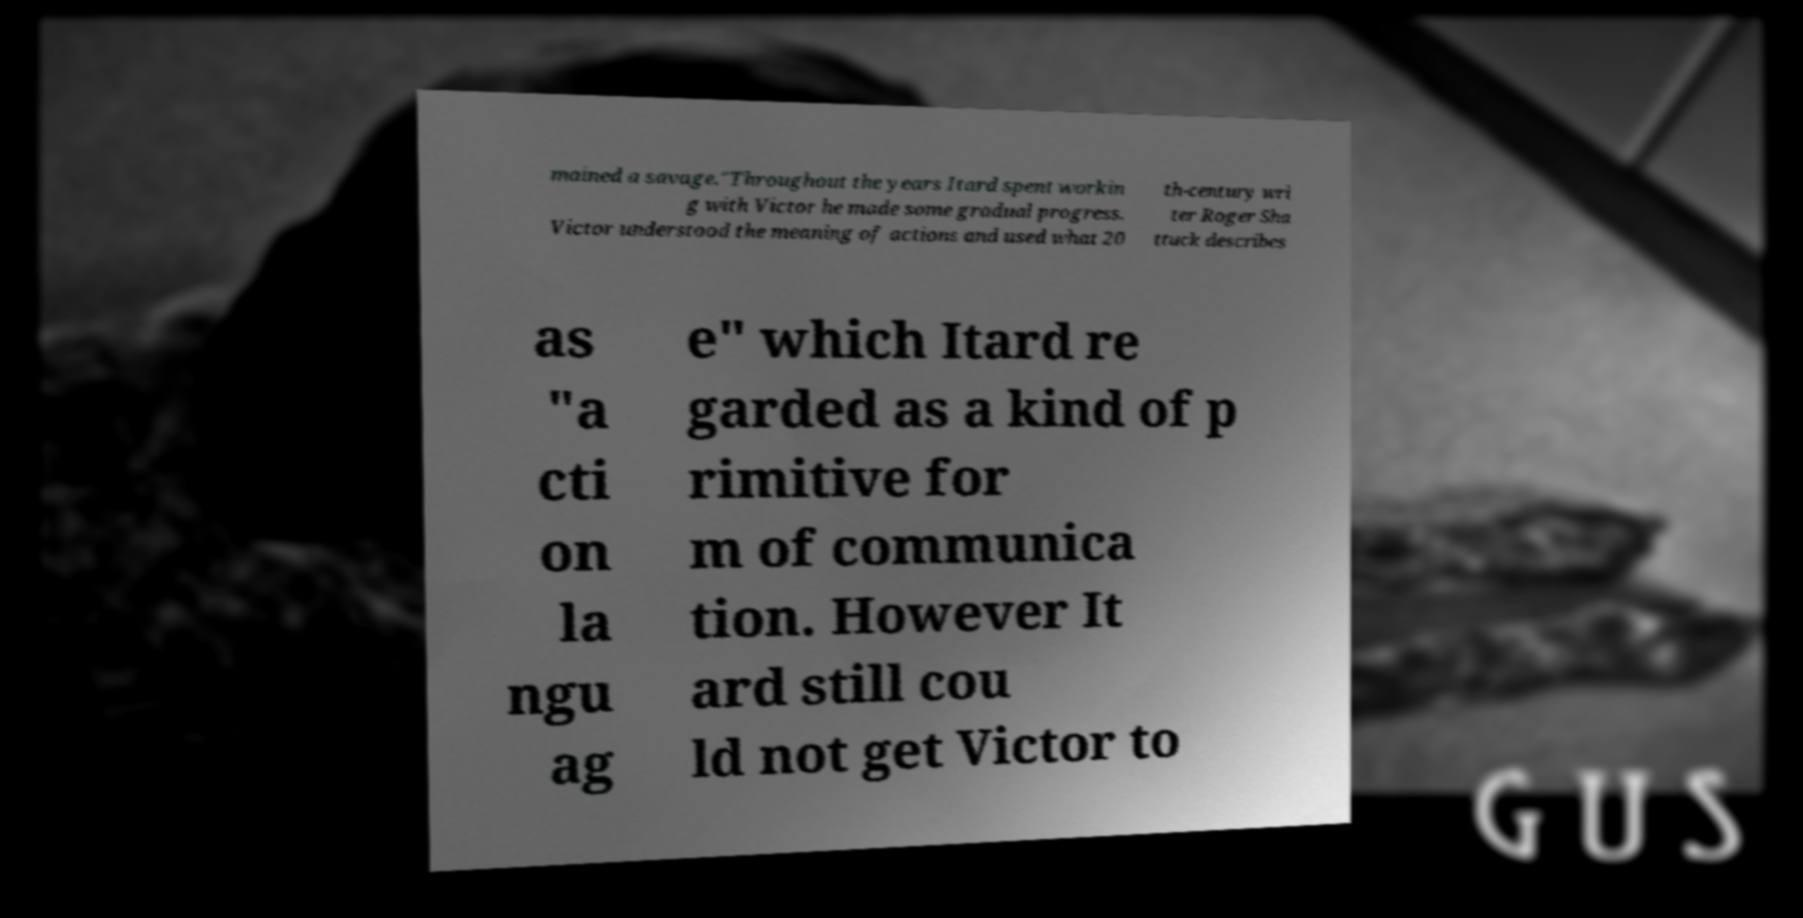For documentation purposes, I need the text within this image transcribed. Could you provide that? mained a savage."Throughout the years Itard spent workin g with Victor he made some gradual progress. Victor understood the meaning of actions and used what 20 th-century wri ter Roger Sha ttuck describes as "a cti on la ngu ag e" which Itard re garded as a kind of p rimitive for m of communica tion. However It ard still cou ld not get Victor to 